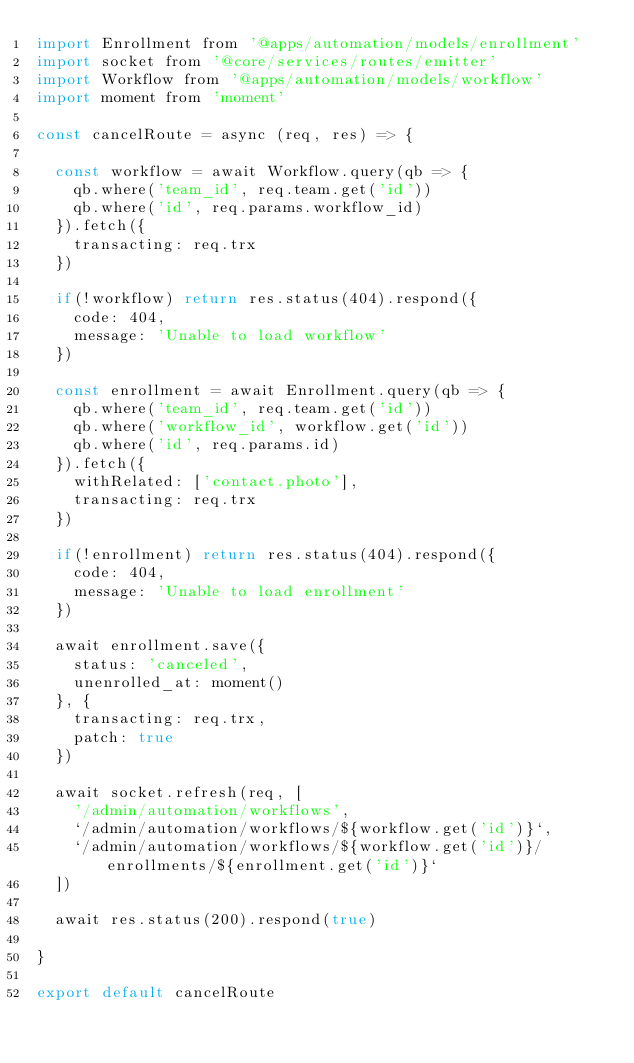Convert code to text. <code><loc_0><loc_0><loc_500><loc_500><_JavaScript_>import Enrollment from '@apps/automation/models/enrollment'
import socket from '@core/services/routes/emitter'
import Workflow from '@apps/automation/models/workflow'
import moment from 'moment'

const cancelRoute = async (req, res) => {

  const workflow = await Workflow.query(qb => {
    qb.where('team_id', req.team.get('id'))
    qb.where('id', req.params.workflow_id)
  }).fetch({
    transacting: req.trx
  })

  if(!workflow) return res.status(404).respond({
    code: 404,
    message: 'Unable to load workflow'
  })

  const enrollment = await Enrollment.query(qb => {
    qb.where('team_id', req.team.get('id'))
    qb.where('workflow_id', workflow.get('id'))
    qb.where('id', req.params.id)
  }).fetch({
    withRelated: ['contact.photo'],
    transacting: req.trx
  })

  if(!enrollment) return res.status(404).respond({
    code: 404,
    message: 'Unable to load enrollment'
  })

  await enrollment.save({
    status: 'canceled',
    unenrolled_at: moment()
  }, {
    transacting: req.trx,
    patch: true
  })

  await socket.refresh(req, [
    '/admin/automation/workflows',
    `/admin/automation/workflows/${workflow.get('id')}`,
    `/admin/automation/workflows/${workflow.get('id')}/enrollments/${enrollment.get('id')}`
  ])

  await res.status(200).respond(true)

}

export default cancelRoute
</code> 